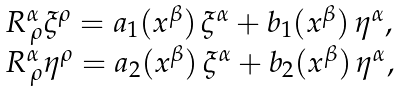<formula> <loc_0><loc_0><loc_500><loc_500>\begin{array} { c c l } & & R ^ { \alpha } _ { \, \rho } \xi ^ { \rho } = a _ { 1 } ( x ^ { \beta } ) \, \xi ^ { \alpha } + b _ { 1 } ( x ^ { \beta } ) \, \eta ^ { \alpha } , \\ & & R ^ { \alpha } _ { \, \rho } \eta ^ { \rho } = a _ { 2 } ( x ^ { \beta } ) \, \xi ^ { \alpha } + b _ { 2 } ( x ^ { \beta } ) \, \eta ^ { \alpha } , \end{array}</formula> 